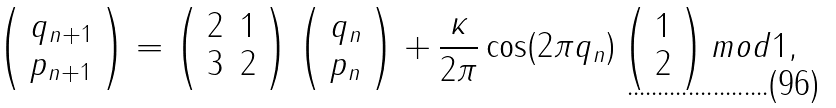<formula> <loc_0><loc_0><loc_500><loc_500>\left ( \begin{array} { l } q _ { n + 1 } \\ p _ { n + 1 } \end{array} \right ) = \left ( \begin{array} { l l } 2 & 1 \\ 3 & 2 \end{array} \right ) \left ( \begin{array} { l } q _ { n } \\ p _ { n } \end{array} \right ) + \frac { \kappa } { 2 \pi } \cos ( 2 \pi q _ { n } ) \left ( \begin{array} { l } 1 \\ 2 \end{array} \right ) m o d 1 ,</formula> 